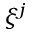<formula> <loc_0><loc_0><loc_500><loc_500>\xi ^ { j }</formula> 